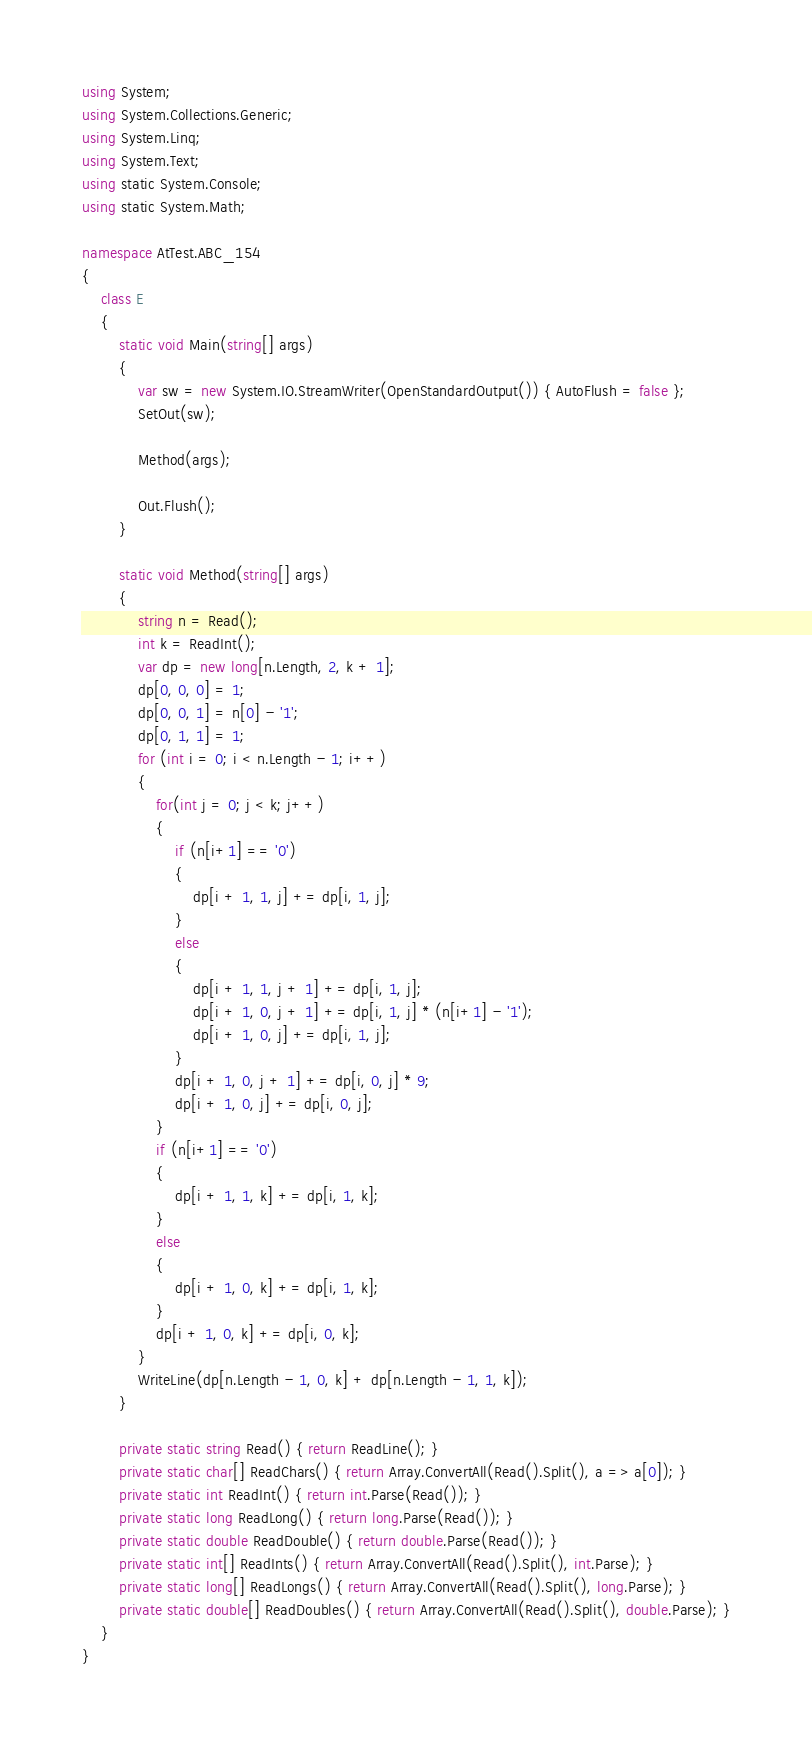<code> <loc_0><loc_0><loc_500><loc_500><_C#_>using System;
using System.Collections.Generic;
using System.Linq;
using System.Text;
using static System.Console;
using static System.Math;

namespace AtTest.ABC_154
{
    class E
    {
        static void Main(string[] args)
        {
            var sw = new System.IO.StreamWriter(OpenStandardOutput()) { AutoFlush = false };
            SetOut(sw);

            Method(args);

            Out.Flush();
        }

        static void Method(string[] args)
        {
            string n = Read();
            int k = ReadInt();
            var dp = new long[n.Length, 2, k + 1];
            dp[0, 0, 0] = 1;
            dp[0, 0, 1] = n[0] - '1';
            dp[0, 1, 1] = 1;
            for (int i = 0; i < n.Length - 1; i++)
            {
                for(int j = 0; j < k; j++)
                {
                    if (n[i+1] == '0')
                    {
                        dp[i + 1, 1, j] += dp[i, 1, j];
                    }
                    else
                    {
                        dp[i + 1, 1, j + 1] += dp[i, 1, j];
                        dp[i + 1, 0, j + 1] += dp[i, 1, j] * (n[i+1] - '1');
                        dp[i + 1, 0, j] += dp[i, 1, j];
                    }
                    dp[i + 1, 0, j + 1] += dp[i, 0, j] * 9;
                    dp[i + 1, 0, j] += dp[i, 0, j];
                }
                if (n[i+1] == '0')
                {
                    dp[i + 1, 1, k] += dp[i, 1, k];
                }
                else
                {
                    dp[i + 1, 0, k] += dp[i, 1, k];
                }
                dp[i + 1, 0, k] += dp[i, 0, k];
            }
            WriteLine(dp[n.Length - 1, 0, k] + dp[n.Length - 1, 1, k]);
        }

        private static string Read() { return ReadLine(); }
        private static char[] ReadChars() { return Array.ConvertAll(Read().Split(), a => a[0]); }
        private static int ReadInt() { return int.Parse(Read()); }
        private static long ReadLong() { return long.Parse(Read()); }
        private static double ReadDouble() { return double.Parse(Read()); }
        private static int[] ReadInts() { return Array.ConvertAll(Read().Split(), int.Parse); }
        private static long[] ReadLongs() { return Array.ConvertAll(Read().Split(), long.Parse); }
        private static double[] ReadDoubles() { return Array.ConvertAll(Read().Split(), double.Parse); }
    }
}
</code> 